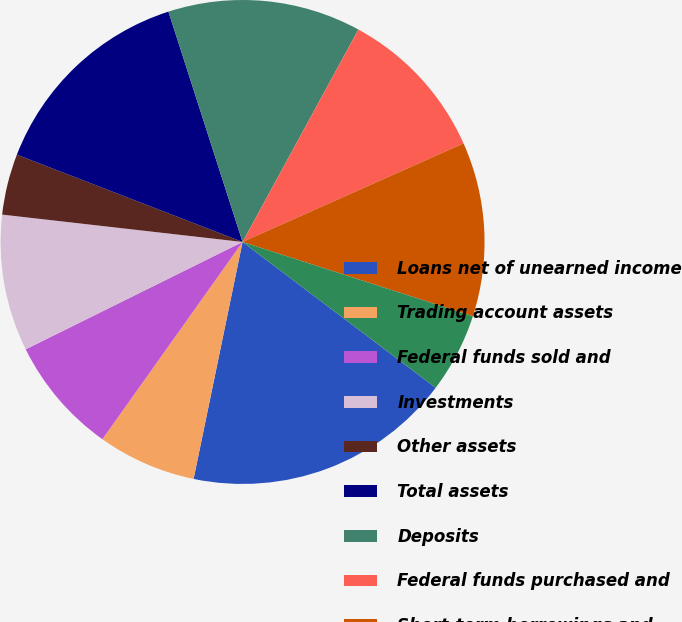<chart> <loc_0><loc_0><loc_500><loc_500><pie_chart><fcel>Loans net of unearned income<fcel>Trading account assets<fcel>Federal funds sold and<fcel>Investments<fcel>Other assets<fcel>Total assets<fcel>Deposits<fcel>Federal funds purchased and<fcel>Short-term borrowings and<fcel>Trading account liabilities<nl><fcel>17.95%<fcel>6.59%<fcel>7.85%<fcel>9.12%<fcel>4.07%<fcel>14.17%<fcel>12.9%<fcel>10.38%<fcel>11.64%<fcel>5.33%<nl></chart> 